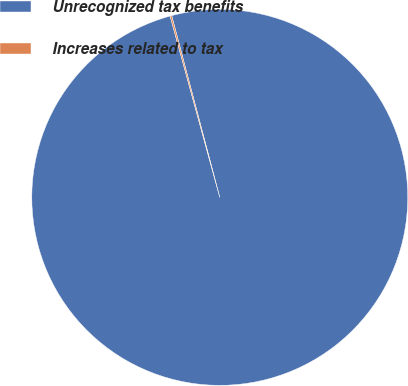Convert chart to OTSL. <chart><loc_0><loc_0><loc_500><loc_500><pie_chart><fcel>Unrecognized tax benefits<fcel>Increases related to tax<nl><fcel>99.86%<fcel>0.14%<nl></chart> 